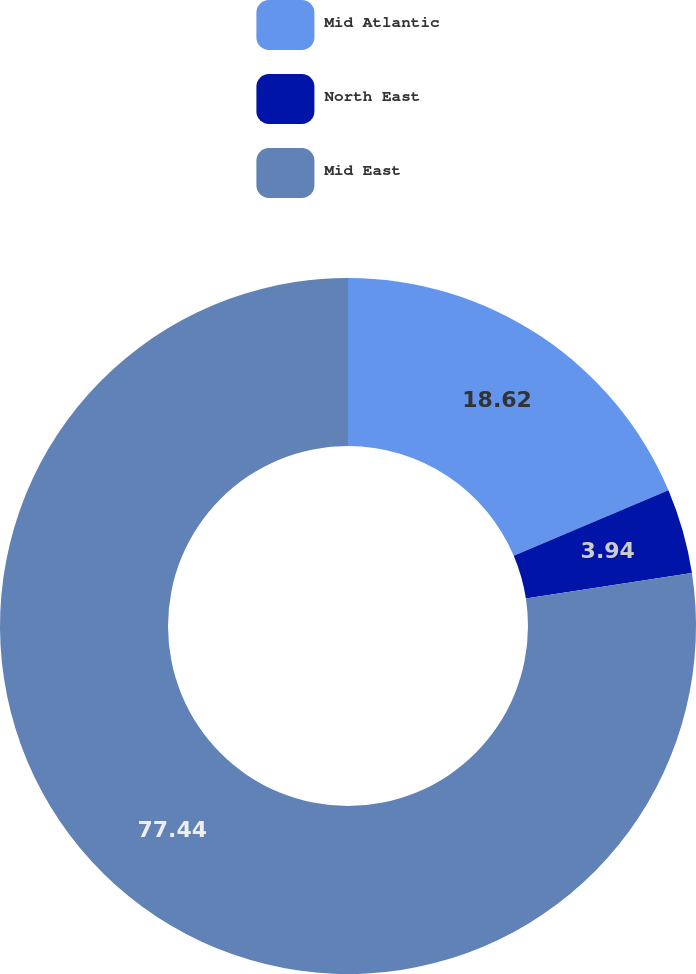Convert chart. <chart><loc_0><loc_0><loc_500><loc_500><pie_chart><fcel>Mid Atlantic<fcel>North East<fcel>Mid East<nl><fcel>18.62%<fcel>3.94%<fcel>77.43%<nl></chart> 